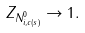<formula> <loc_0><loc_0><loc_500><loc_500>Z _ { N ^ { 0 } _ { i , c ( s ) } } \to 1 .</formula> 